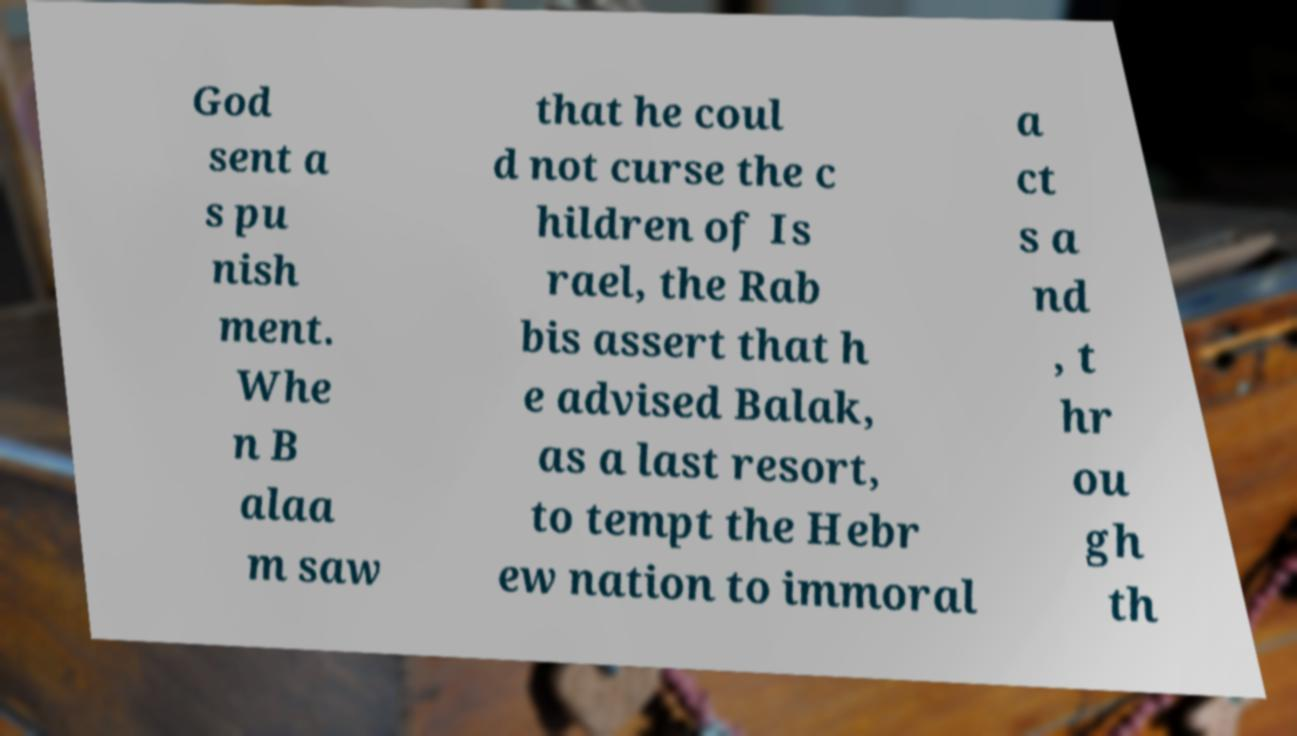For documentation purposes, I need the text within this image transcribed. Could you provide that? God sent a s pu nish ment. Whe n B alaa m saw that he coul d not curse the c hildren of Is rael, the Rab bis assert that h e advised Balak, as a last resort, to tempt the Hebr ew nation to immoral a ct s a nd , t hr ou gh th 